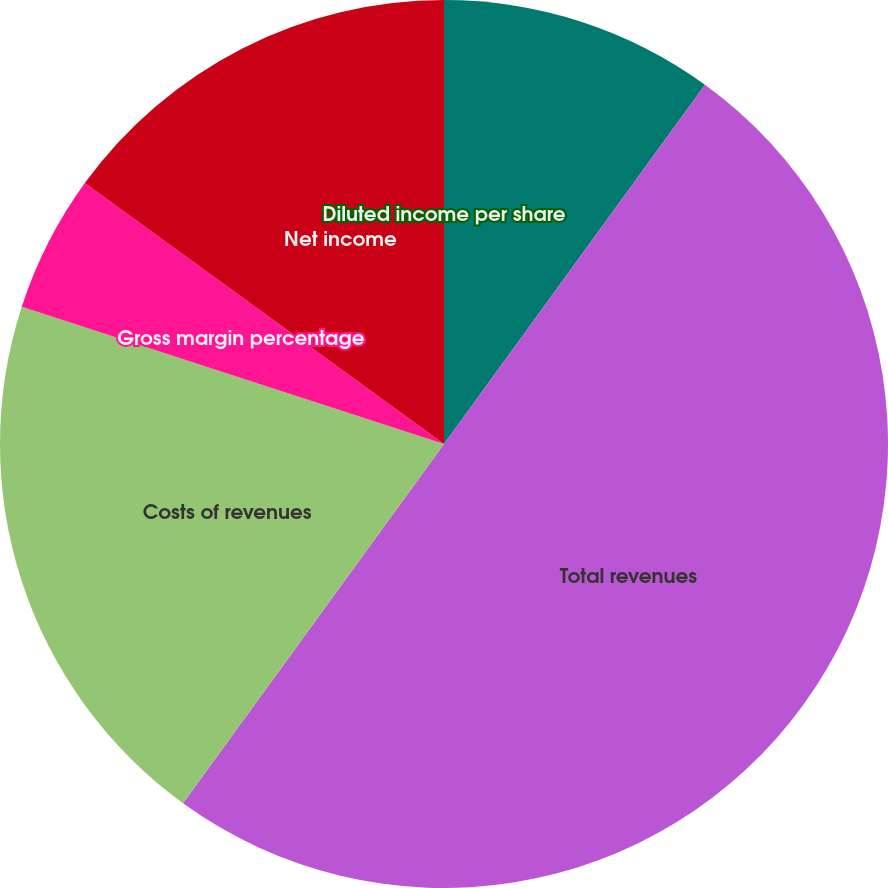Convert chart to OTSL. <chart><loc_0><loc_0><loc_500><loc_500><pie_chart><fcel>(Dollar amounts in thousands)<fcel>Total revenues<fcel>Costs of revenues<fcel>Gross margin percentage<fcel>Net income<fcel>Diluted income per share<nl><fcel>10.0%<fcel>50.0%<fcel>20.0%<fcel>5.0%<fcel>15.0%<fcel>0.0%<nl></chart> 